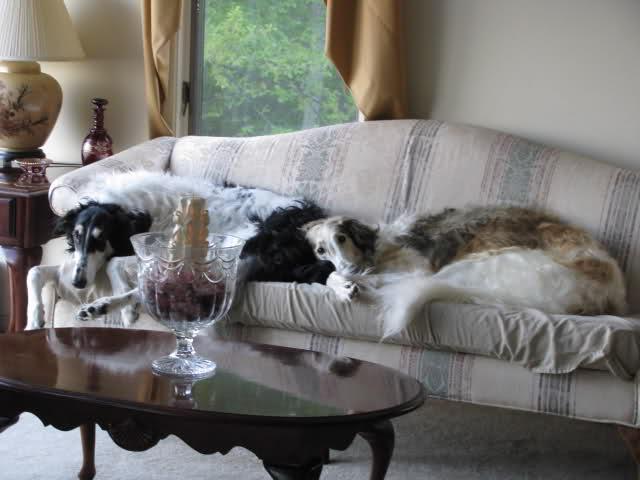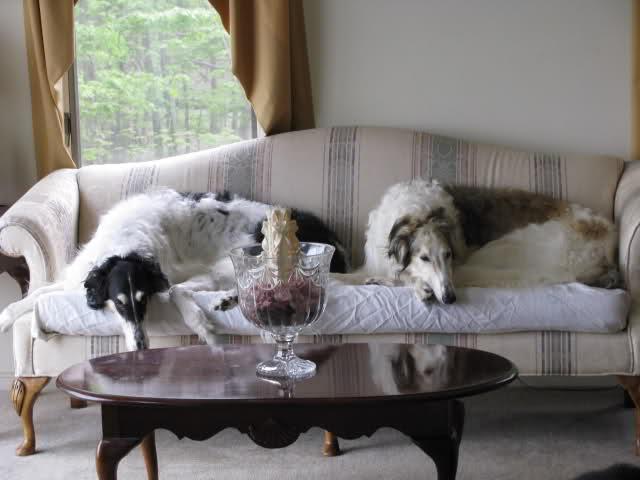The first image is the image on the left, the second image is the image on the right. Analyze the images presented: Is the assertion "The right image contains at least two dogs laying down on a couch." valid? Answer yes or no. Yes. The first image is the image on the left, the second image is the image on the right. Evaluate the accuracy of this statement regarding the images: "There are two dogs lying on the couch in the image on the right.". Is it true? Answer yes or no. Yes. 